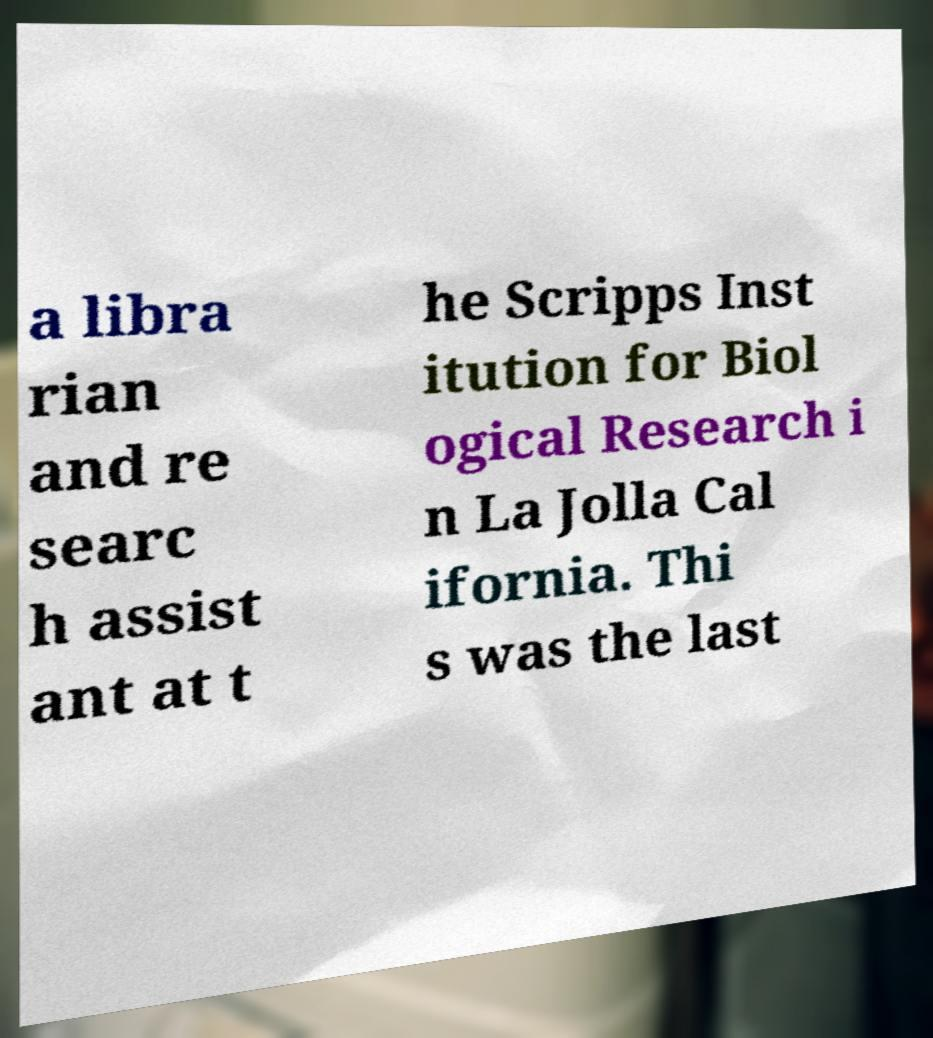Could you extract and type out the text from this image? a libra rian and re searc h assist ant at t he Scripps Inst itution for Biol ogical Research i n La Jolla Cal ifornia. Thi s was the last 